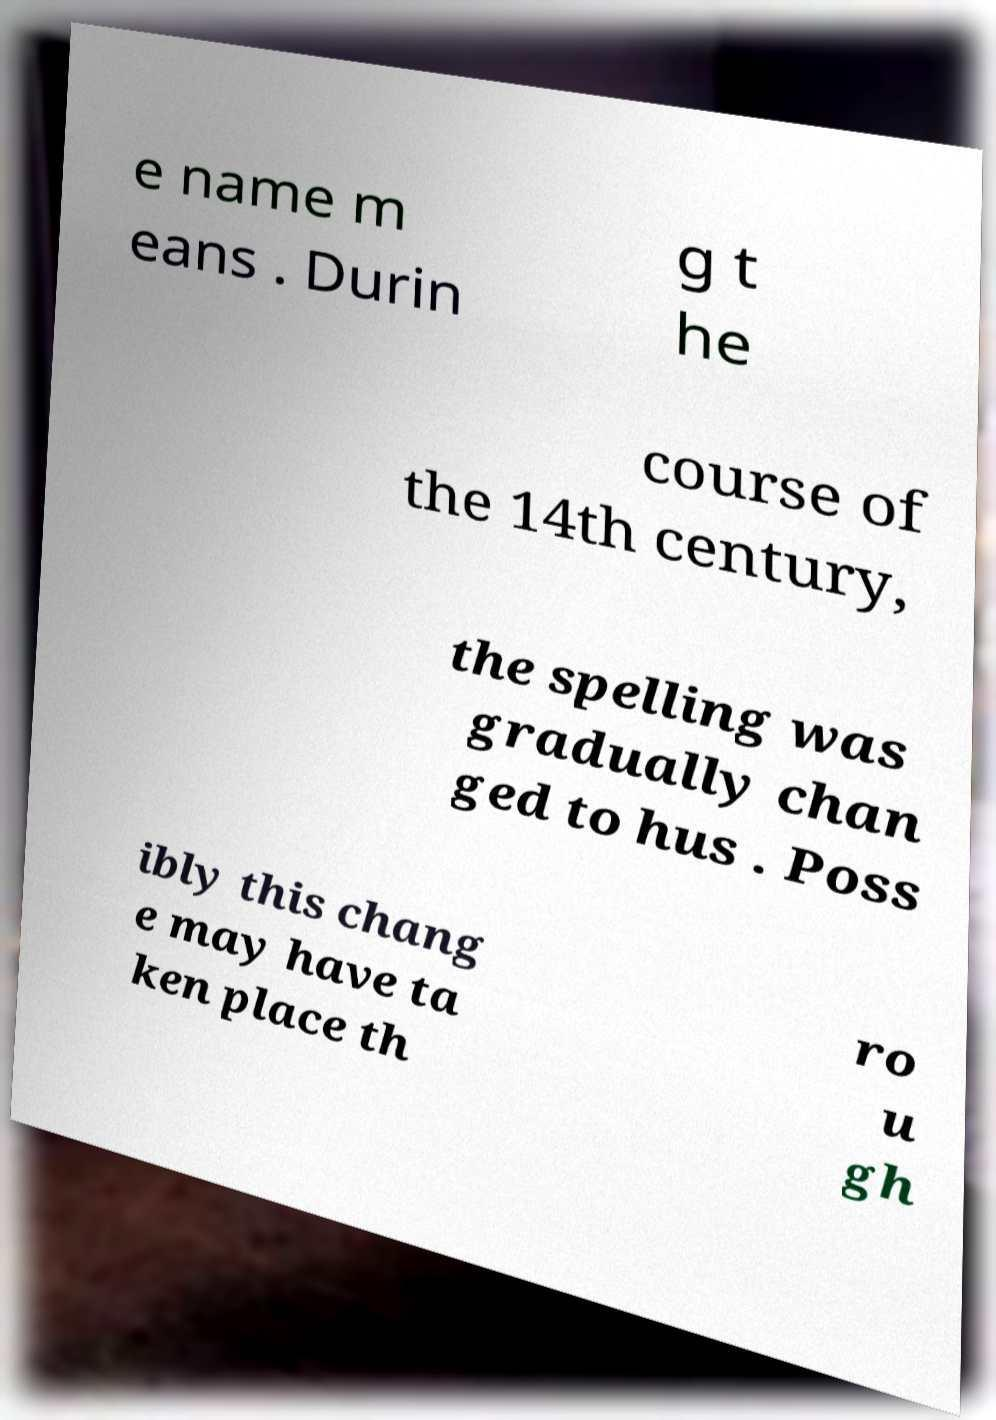Can you read and provide the text displayed in the image?This photo seems to have some interesting text. Can you extract and type it out for me? e name m eans . Durin g t he course of the 14th century, the spelling was gradually chan ged to hus . Poss ibly this chang e may have ta ken place th ro u gh 